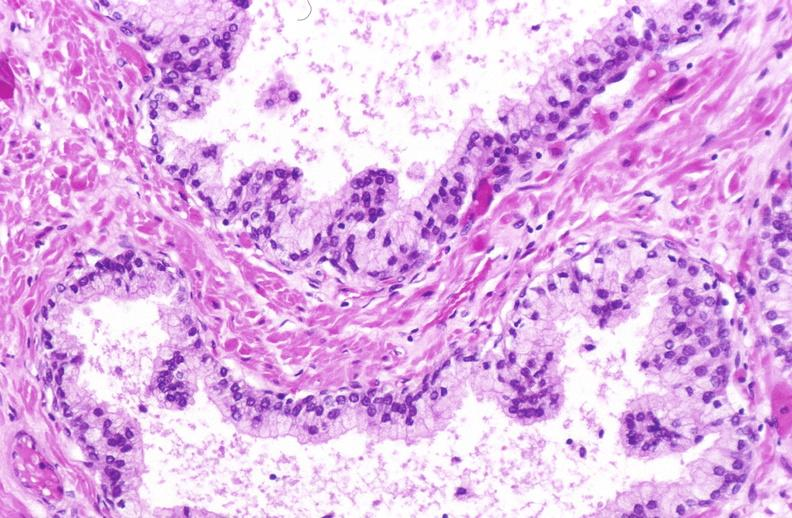does this image show normal prostate?
Answer the question using a single word or phrase. Yes 